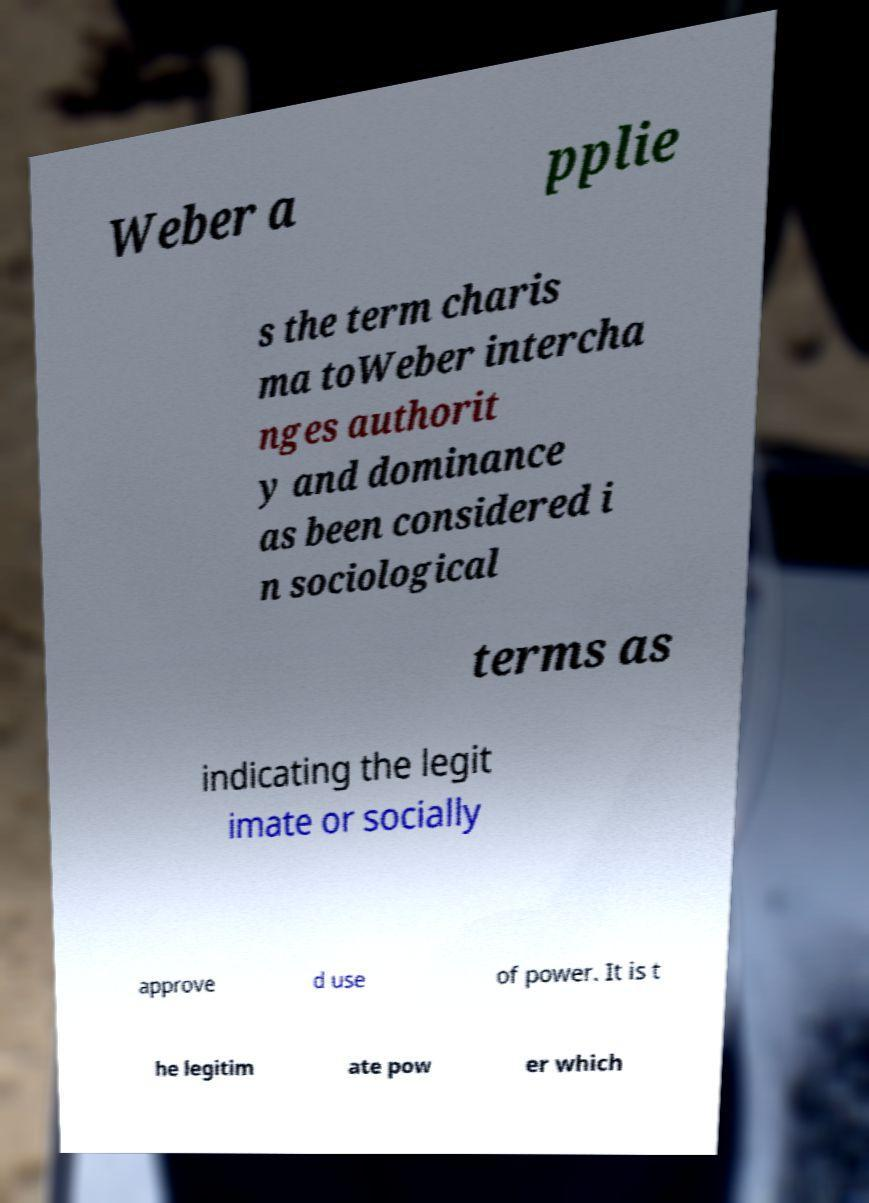Please identify and transcribe the text found in this image. Weber a pplie s the term charis ma toWeber intercha nges authorit y and dominance as been considered i n sociological terms as indicating the legit imate or socially approve d use of power. It is t he legitim ate pow er which 